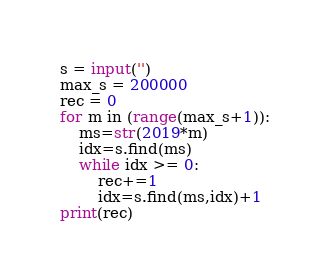Convert code to text. <code><loc_0><loc_0><loc_500><loc_500><_Python_>
s = input('')
max_s = 200000
rec = 0
for m in (range(max_s+1)):
    ms=str(2019*m)
    idx=s.find(ms)
    while idx >= 0:
        rec+=1
        idx=s.find(ms,idx)+1
print(rec)
</code> 